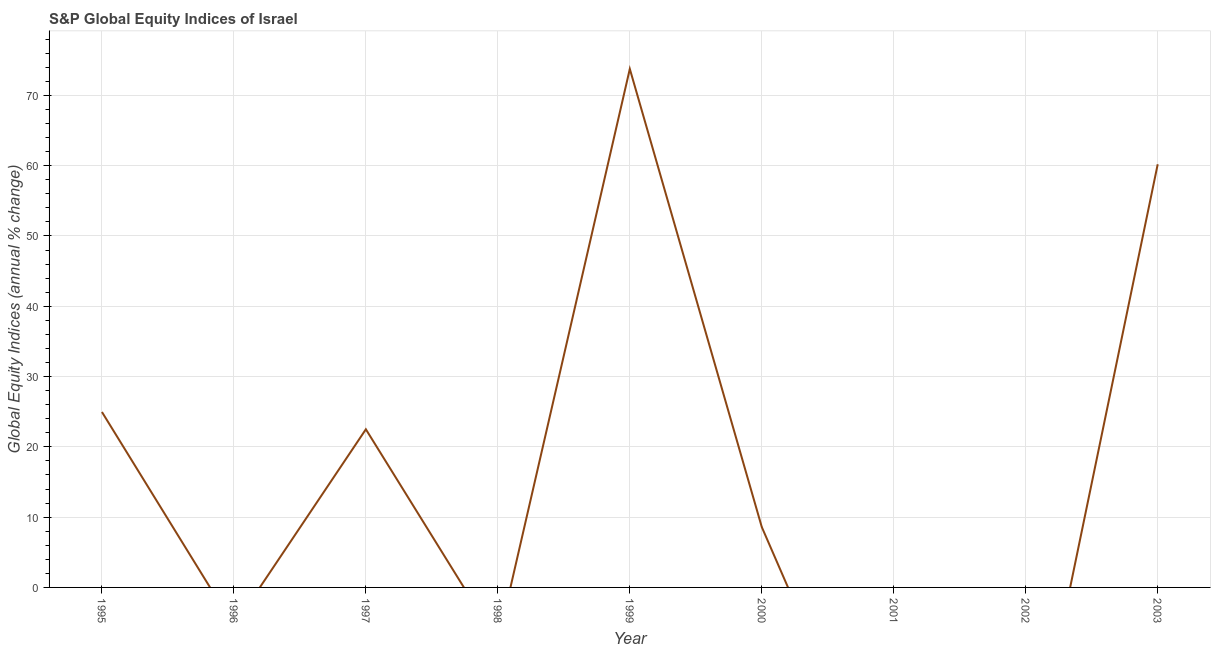What is the s&p global equity indices in 1996?
Provide a succinct answer. 0. Across all years, what is the maximum s&p global equity indices?
Give a very brief answer. 73.76. In which year was the s&p global equity indices maximum?
Your response must be concise. 1999. What is the sum of the s&p global equity indices?
Provide a succinct answer. 190. What is the difference between the s&p global equity indices in 1999 and 2003?
Ensure brevity in your answer.  13.56. What is the average s&p global equity indices per year?
Offer a very short reply. 21.11. What is the median s&p global equity indices?
Give a very brief answer. 8.59. Is the s&p global equity indices in 1999 less than that in 2000?
Give a very brief answer. No. What is the difference between the highest and the second highest s&p global equity indices?
Offer a very short reply. 13.56. What is the difference between the highest and the lowest s&p global equity indices?
Offer a very short reply. 73.76. Does the s&p global equity indices monotonically increase over the years?
Your answer should be compact. No. How many years are there in the graph?
Keep it short and to the point. 9. Does the graph contain any zero values?
Keep it short and to the point. Yes. What is the title of the graph?
Ensure brevity in your answer.  S&P Global Equity Indices of Israel. What is the label or title of the X-axis?
Offer a very short reply. Year. What is the label or title of the Y-axis?
Your response must be concise. Global Equity Indices (annual % change). What is the Global Equity Indices (annual % change) in 1995?
Ensure brevity in your answer.  24.96. What is the Global Equity Indices (annual % change) of 1997?
Give a very brief answer. 22.5. What is the Global Equity Indices (annual % change) of 1999?
Offer a very short reply. 73.76. What is the Global Equity Indices (annual % change) of 2000?
Your answer should be compact. 8.59. What is the Global Equity Indices (annual % change) in 2002?
Your response must be concise. 0. What is the Global Equity Indices (annual % change) of 2003?
Your answer should be very brief. 60.2. What is the difference between the Global Equity Indices (annual % change) in 1995 and 1997?
Offer a very short reply. 2.46. What is the difference between the Global Equity Indices (annual % change) in 1995 and 1999?
Make the answer very short. -48.8. What is the difference between the Global Equity Indices (annual % change) in 1995 and 2000?
Make the answer very short. 16.37. What is the difference between the Global Equity Indices (annual % change) in 1995 and 2003?
Provide a succinct answer. -35.24. What is the difference between the Global Equity Indices (annual % change) in 1997 and 1999?
Make the answer very short. -51.27. What is the difference between the Global Equity Indices (annual % change) in 1997 and 2000?
Provide a short and direct response. 13.91. What is the difference between the Global Equity Indices (annual % change) in 1997 and 2003?
Make the answer very short. -37.7. What is the difference between the Global Equity Indices (annual % change) in 1999 and 2000?
Ensure brevity in your answer.  65.17. What is the difference between the Global Equity Indices (annual % change) in 1999 and 2003?
Ensure brevity in your answer.  13.56. What is the difference between the Global Equity Indices (annual % change) in 2000 and 2003?
Provide a succinct answer. -51.61. What is the ratio of the Global Equity Indices (annual % change) in 1995 to that in 1997?
Provide a succinct answer. 1.11. What is the ratio of the Global Equity Indices (annual % change) in 1995 to that in 1999?
Give a very brief answer. 0.34. What is the ratio of the Global Equity Indices (annual % change) in 1995 to that in 2000?
Your response must be concise. 2.91. What is the ratio of the Global Equity Indices (annual % change) in 1995 to that in 2003?
Your answer should be compact. 0.41. What is the ratio of the Global Equity Indices (annual % change) in 1997 to that in 1999?
Give a very brief answer. 0.3. What is the ratio of the Global Equity Indices (annual % change) in 1997 to that in 2000?
Your answer should be very brief. 2.62. What is the ratio of the Global Equity Indices (annual % change) in 1997 to that in 2003?
Your answer should be very brief. 0.37. What is the ratio of the Global Equity Indices (annual % change) in 1999 to that in 2000?
Make the answer very short. 8.59. What is the ratio of the Global Equity Indices (annual % change) in 1999 to that in 2003?
Keep it short and to the point. 1.23. What is the ratio of the Global Equity Indices (annual % change) in 2000 to that in 2003?
Provide a short and direct response. 0.14. 